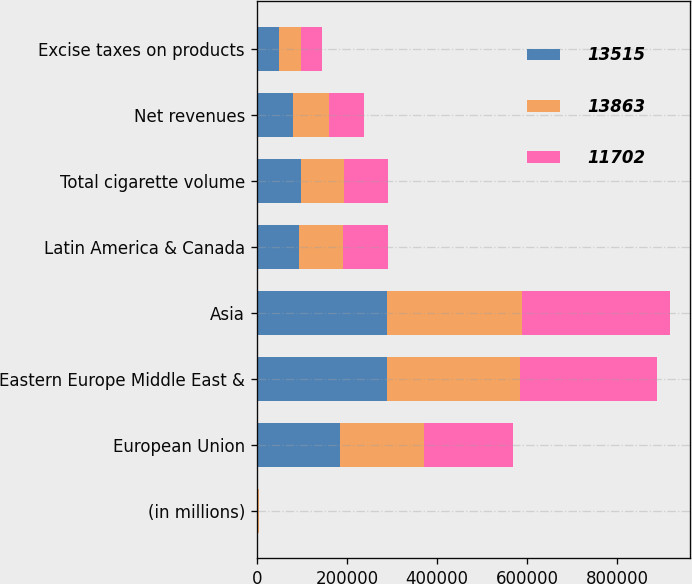Convert chart. <chart><loc_0><loc_0><loc_500><loc_500><stacked_bar_chart><ecel><fcel>(in millions)<fcel>European Union<fcel>Eastern Europe Middle East &<fcel>Asia<fcel>Latin America & Canada<fcel>Total cigarette volume<fcel>Net revenues<fcel>Excise taxes on products<nl><fcel>13515<fcel>2014<fcel>185197<fcel>287923<fcel>288128<fcel>94706<fcel>97287<fcel>80106<fcel>50339<nl><fcel>13863<fcel>2013<fcel>185096<fcel>296462<fcel>301324<fcel>97287<fcel>97287<fcel>80029<fcel>48812<nl><fcel>11702<fcel>2012<fcel>197966<fcel>303828<fcel>326582<fcel>98660<fcel>97287<fcel>77393<fcel>46016<nl></chart> 